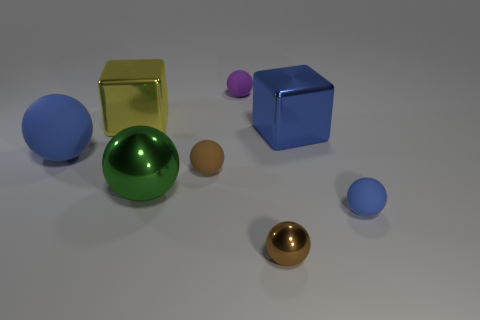Subtract all green balls. How many balls are left? 5 Subtract all large green balls. How many balls are left? 5 Subtract all gray spheres. Subtract all brown blocks. How many spheres are left? 6 Add 1 small purple matte things. How many objects exist? 9 Subtract all cubes. How many objects are left? 6 Subtract 0 cyan spheres. How many objects are left? 8 Subtract all tiny brown matte objects. Subtract all small purple spheres. How many objects are left? 6 Add 5 green objects. How many green objects are left? 6 Add 1 big purple metal things. How many big purple metal things exist? 1 